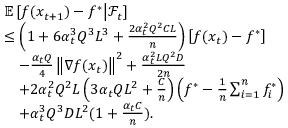<formula> <loc_0><loc_0><loc_500><loc_500>\begin{array} { r l } & { \mathbb { E } \left [ f ( x _ { t + 1 } ) - f ^ { * } | d l e | \mathcal { F } _ { t } \right ] } \\ & { \leq \left ( 1 + 6 \alpha _ { t } ^ { 3 } Q ^ { 3 } L ^ { 3 } + \frac { 2 \alpha _ { t } ^ { 2 } Q ^ { 2 } C L } { n } \right ) \left [ f ( x _ { t } ) - f ^ { * } \right ] } \\ & { \quad - \frac { \alpha _ { t } Q } { 4 } \left \| \nabla f ( x _ { t } ) \right \| ^ { 2 } + \frac { \alpha _ { t } ^ { 2 } L Q ^ { 2 } D } { 2 n } } \\ & { \quad + 2 \alpha _ { t } ^ { 2 } Q ^ { 2 } L \left ( 3 \alpha _ { t } Q L ^ { 2 } + \frac { C } { n } \right ) \left ( f ^ { * } - \frac { 1 } { n } \sum _ { i = 1 } ^ { n } f _ { i } ^ { * } \right ) } \\ & { \quad + \alpha _ { t } ^ { 3 } Q ^ { 3 } D L ^ { 2 } ( 1 + \frac { \alpha _ { t } C } { n } ) . } \end{array}</formula> 